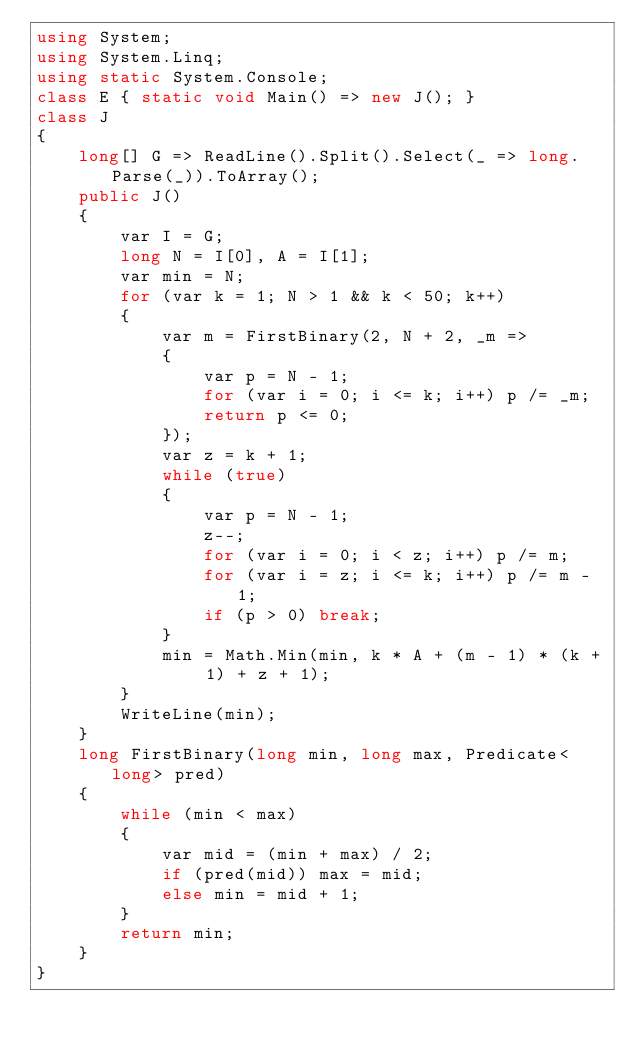Convert code to text. <code><loc_0><loc_0><loc_500><loc_500><_C#_>using System;
using System.Linq;
using static System.Console;
class E { static void Main() => new J(); }
class J
{
	long[] G => ReadLine().Split().Select(_ => long.Parse(_)).ToArray();
	public J()
	{
		var I = G;
		long N = I[0], A = I[1];
		var min = N;
		for (var k = 1; N > 1 && k < 50; k++)
		{
			var m = FirstBinary(2, N + 2, _m =>
			{
				var p = N - 1;
				for (var i = 0; i <= k; i++) p /= _m;
				return p <= 0;
			});
			var z = k + 1;
			while (true)
			{
				var p = N - 1;
				z--;
				for (var i = 0; i < z; i++) p /= m;
				for (var i = z; i <= k; i++) p /= m - 1;
				if (p > 0) break;
			}
			min = Math.Min(min, k * A + (m - 1) * (k + 1) + z + 1);
		}
		WriteLine(min);
	}
	long FirstBinary(long min, long max, Predicate<long> pred)
	{
		while (min < max)
		{
			var mid = (min + max) / 2;
			if (pred(mid)) max = mid;
			else min = mid + 1;
		}
		return min;
	}
}</code> 